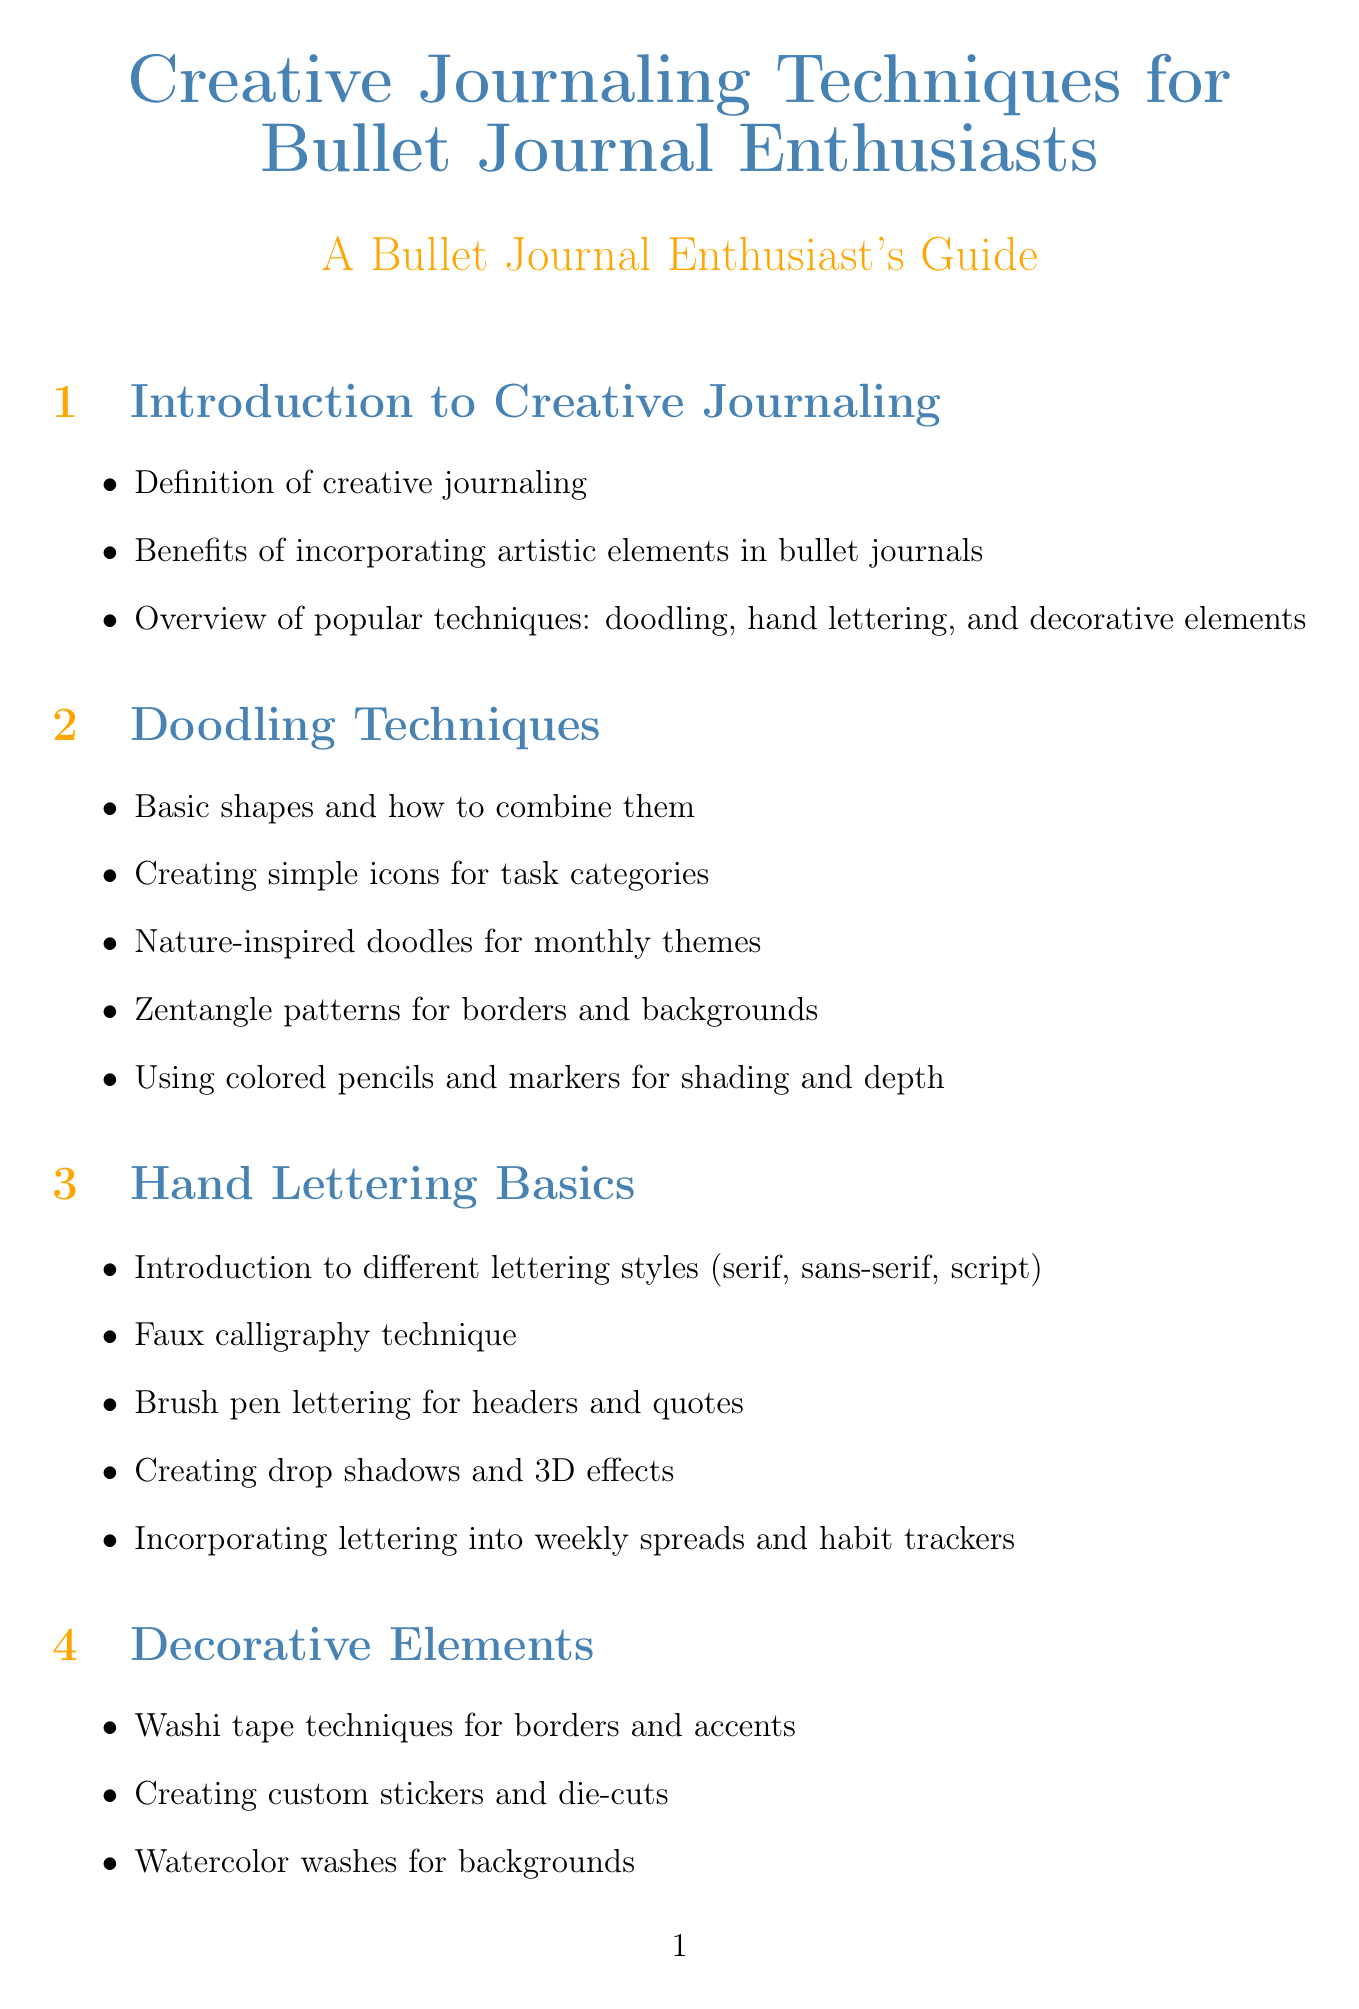What are the popular techniques in creative journaling? The document lists popular techniques as doodling, hand lettering, and decorative elements.
Answer: doodling, hand lettering, decorative elements What is one benefit of artistic elements in bullet journals? The document mentions benefits that include enhancing organization and creativity.
Answer: enhancing organization Which tool is recommended for watercolor? The document includes a watercolor paint set in the recommended tools section.
Answer: watercolor paint set What does faux calligraphy refer to? Faux calligraphy is defined as a lettering technique mentioned in the hand lettering basics section.
Answer: lettering technique How many sections are there in the document? The document has a total of eight main sections, each covering different aspects of creative journaling.
Answer: eight What is an example of a seasonal element in journaling? Seasonal elements can be incorporated into monthly layouts as mentioned in the seasonal journaling section.
Answer: monthly layouts Which artist is credited as the Bullet Journal creator? Ryder Carroll is specifically mentioned as the creator of the Bullet Journal in the inspirational artists section.
Answer: Ryder Carroll What website is listed as a helpful community? The Reddit community r/bulletjournal is noted as a helpful website in the document.
Answer: r/bulletjournal What is a primary focus of the color theory section? The section on color theory primarily focuses on creating cohesive color schemes and understanding color basics.
Answer: cohesive color schemes 